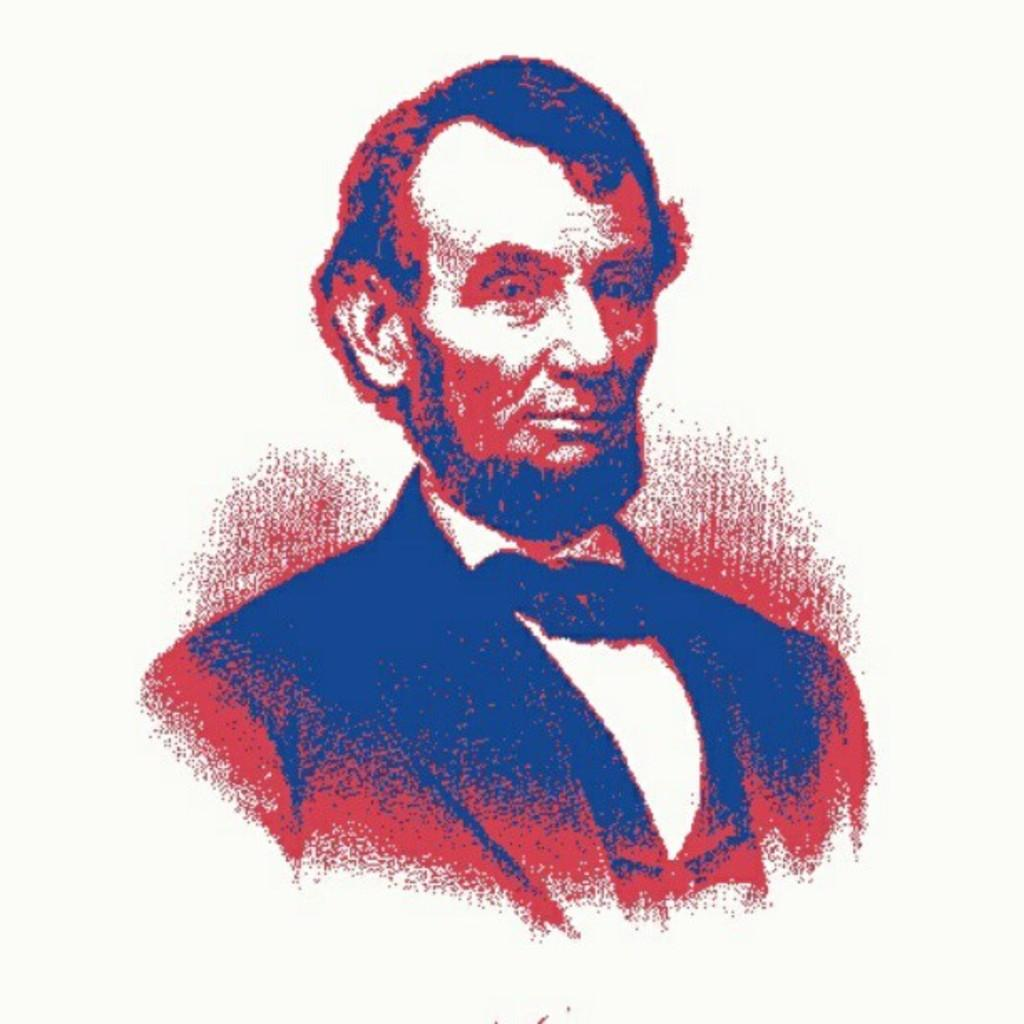Who is present in the image? There is a man in the image. What is the man wearing? The man is wearing a suit. What colors of paint are on the man? The man has red and blue color paint on him. What type of quilt is being used in the fight scene in the image? There is no fight scene or quilt present in the image; it features a man wearing a suit with red and blue paint on him. 